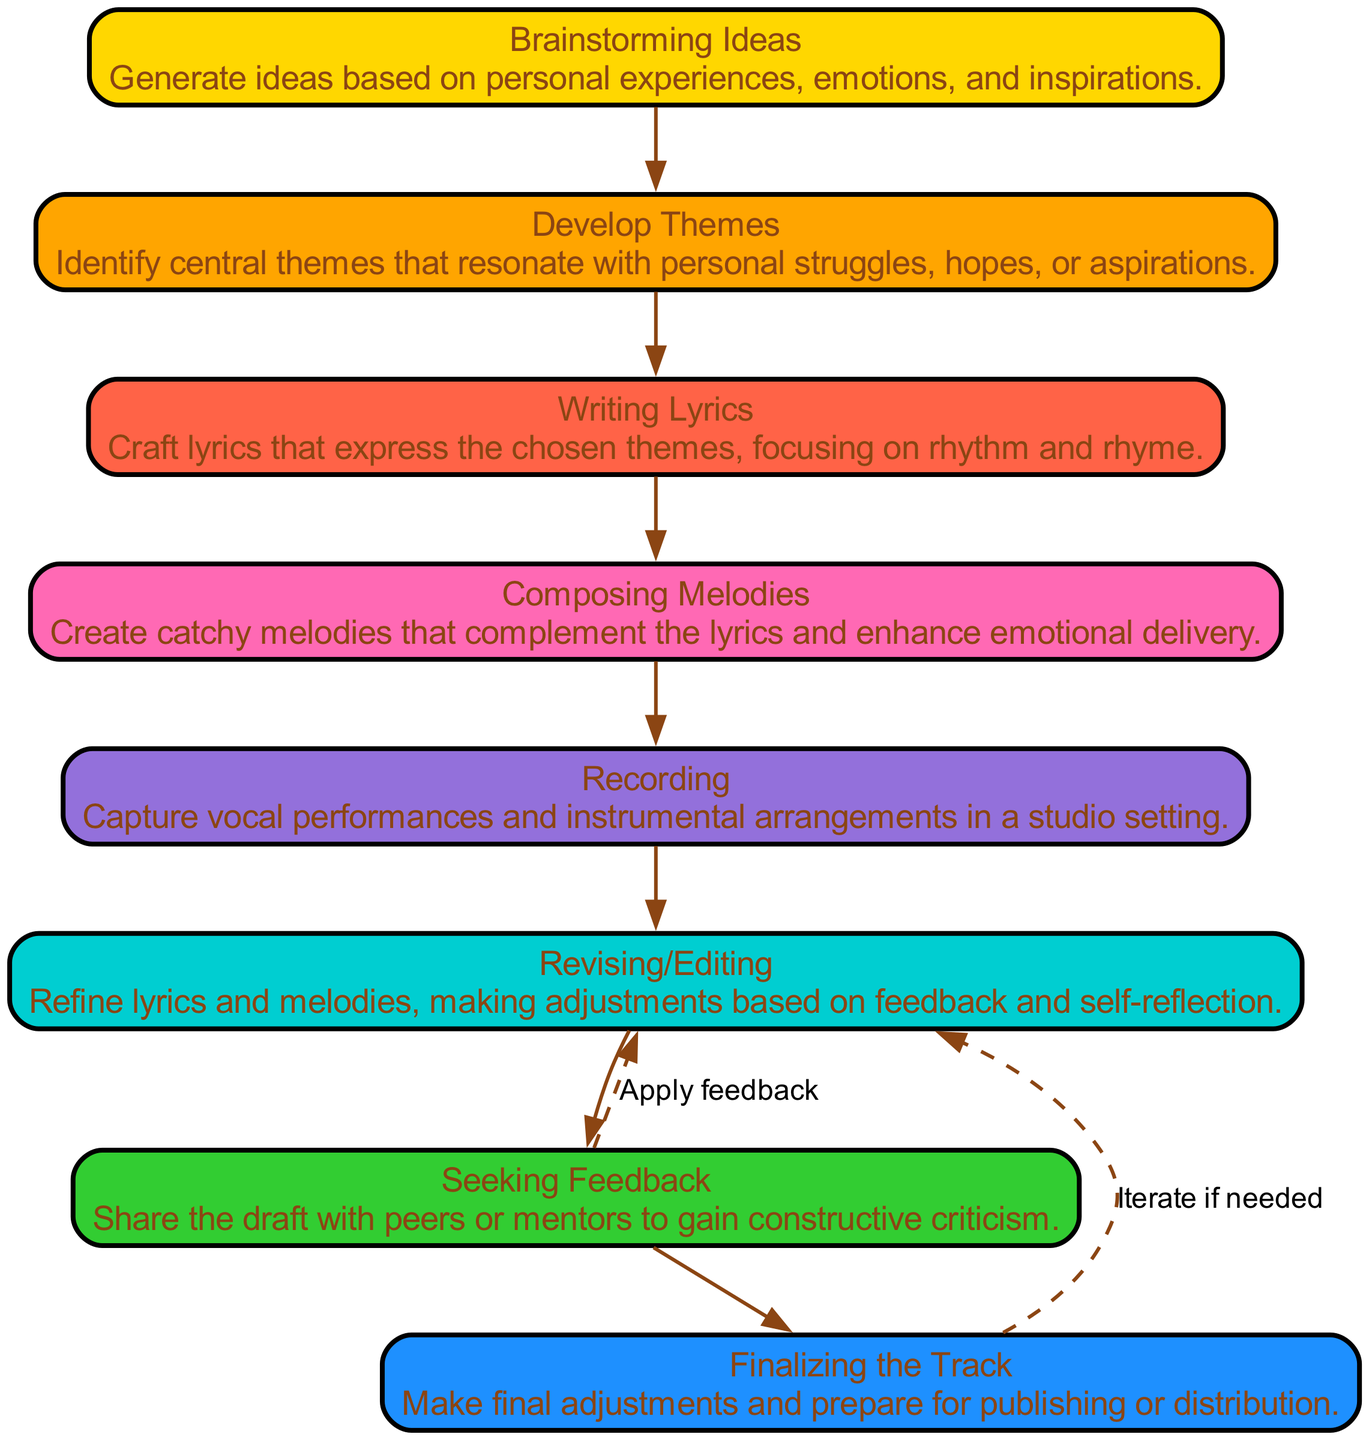What is the first step in the songwriting process? The diagram indicates "Brainstorming Ideas" as the first step, meaning it is where one starts generating ideas based on personal experiences.
Answer: Brainstorming Ideas How many steps are shown in the diagram? By counting the nodes, there are a total of eight distinct steps outlined in the songwriting process from brainstorming to finalizing the track.
Answer: Eight What is the last step before finalizing the track? The step immediately before "Finalizing the Track" is "Seeking Feedback," which involves sharing the draft with peers or mentors for constructive criticism.
Answer: Seeking Feedback What step comes after revising? The diagram shows that after "Revising/Editing," the next step is "Finalizing the Track," which includes making final adjustments for publishing.
Answer: Finalizing the Track Which two steps have a feedback loop connecting to revising? "Seeking Feedback" and "Finalizing the Track" both connect to "Revising" to indicate that revisions may need to be applied based on feedback and final adjustments.
Answer: Seeking Feedback, Finalizing the Track Which theme is emphasized in "Develop Themes"? The "Develop Themes" step emphasizes identifying central themes that resonate with personal struggles, hopes, or aspirations, highlighting the emotional core of songwriting.
Answer: Personal struggles, hopes, aspirations How does one transition from writing lyrics to composing melodies? The flow chart indicates a direct progression from "Writing Lyrics" to "Composing Melodies," suggesting that lyric writing is likely completed before melody creation begins.
Answer: Direct progression Which color is used for the "Composing Melodies" node? In the flow chart, "Composing Melodies" is represented with a custom color that corresponds to the established color palette, specifically the fifth color from the provided list.
Answer: Lavander 